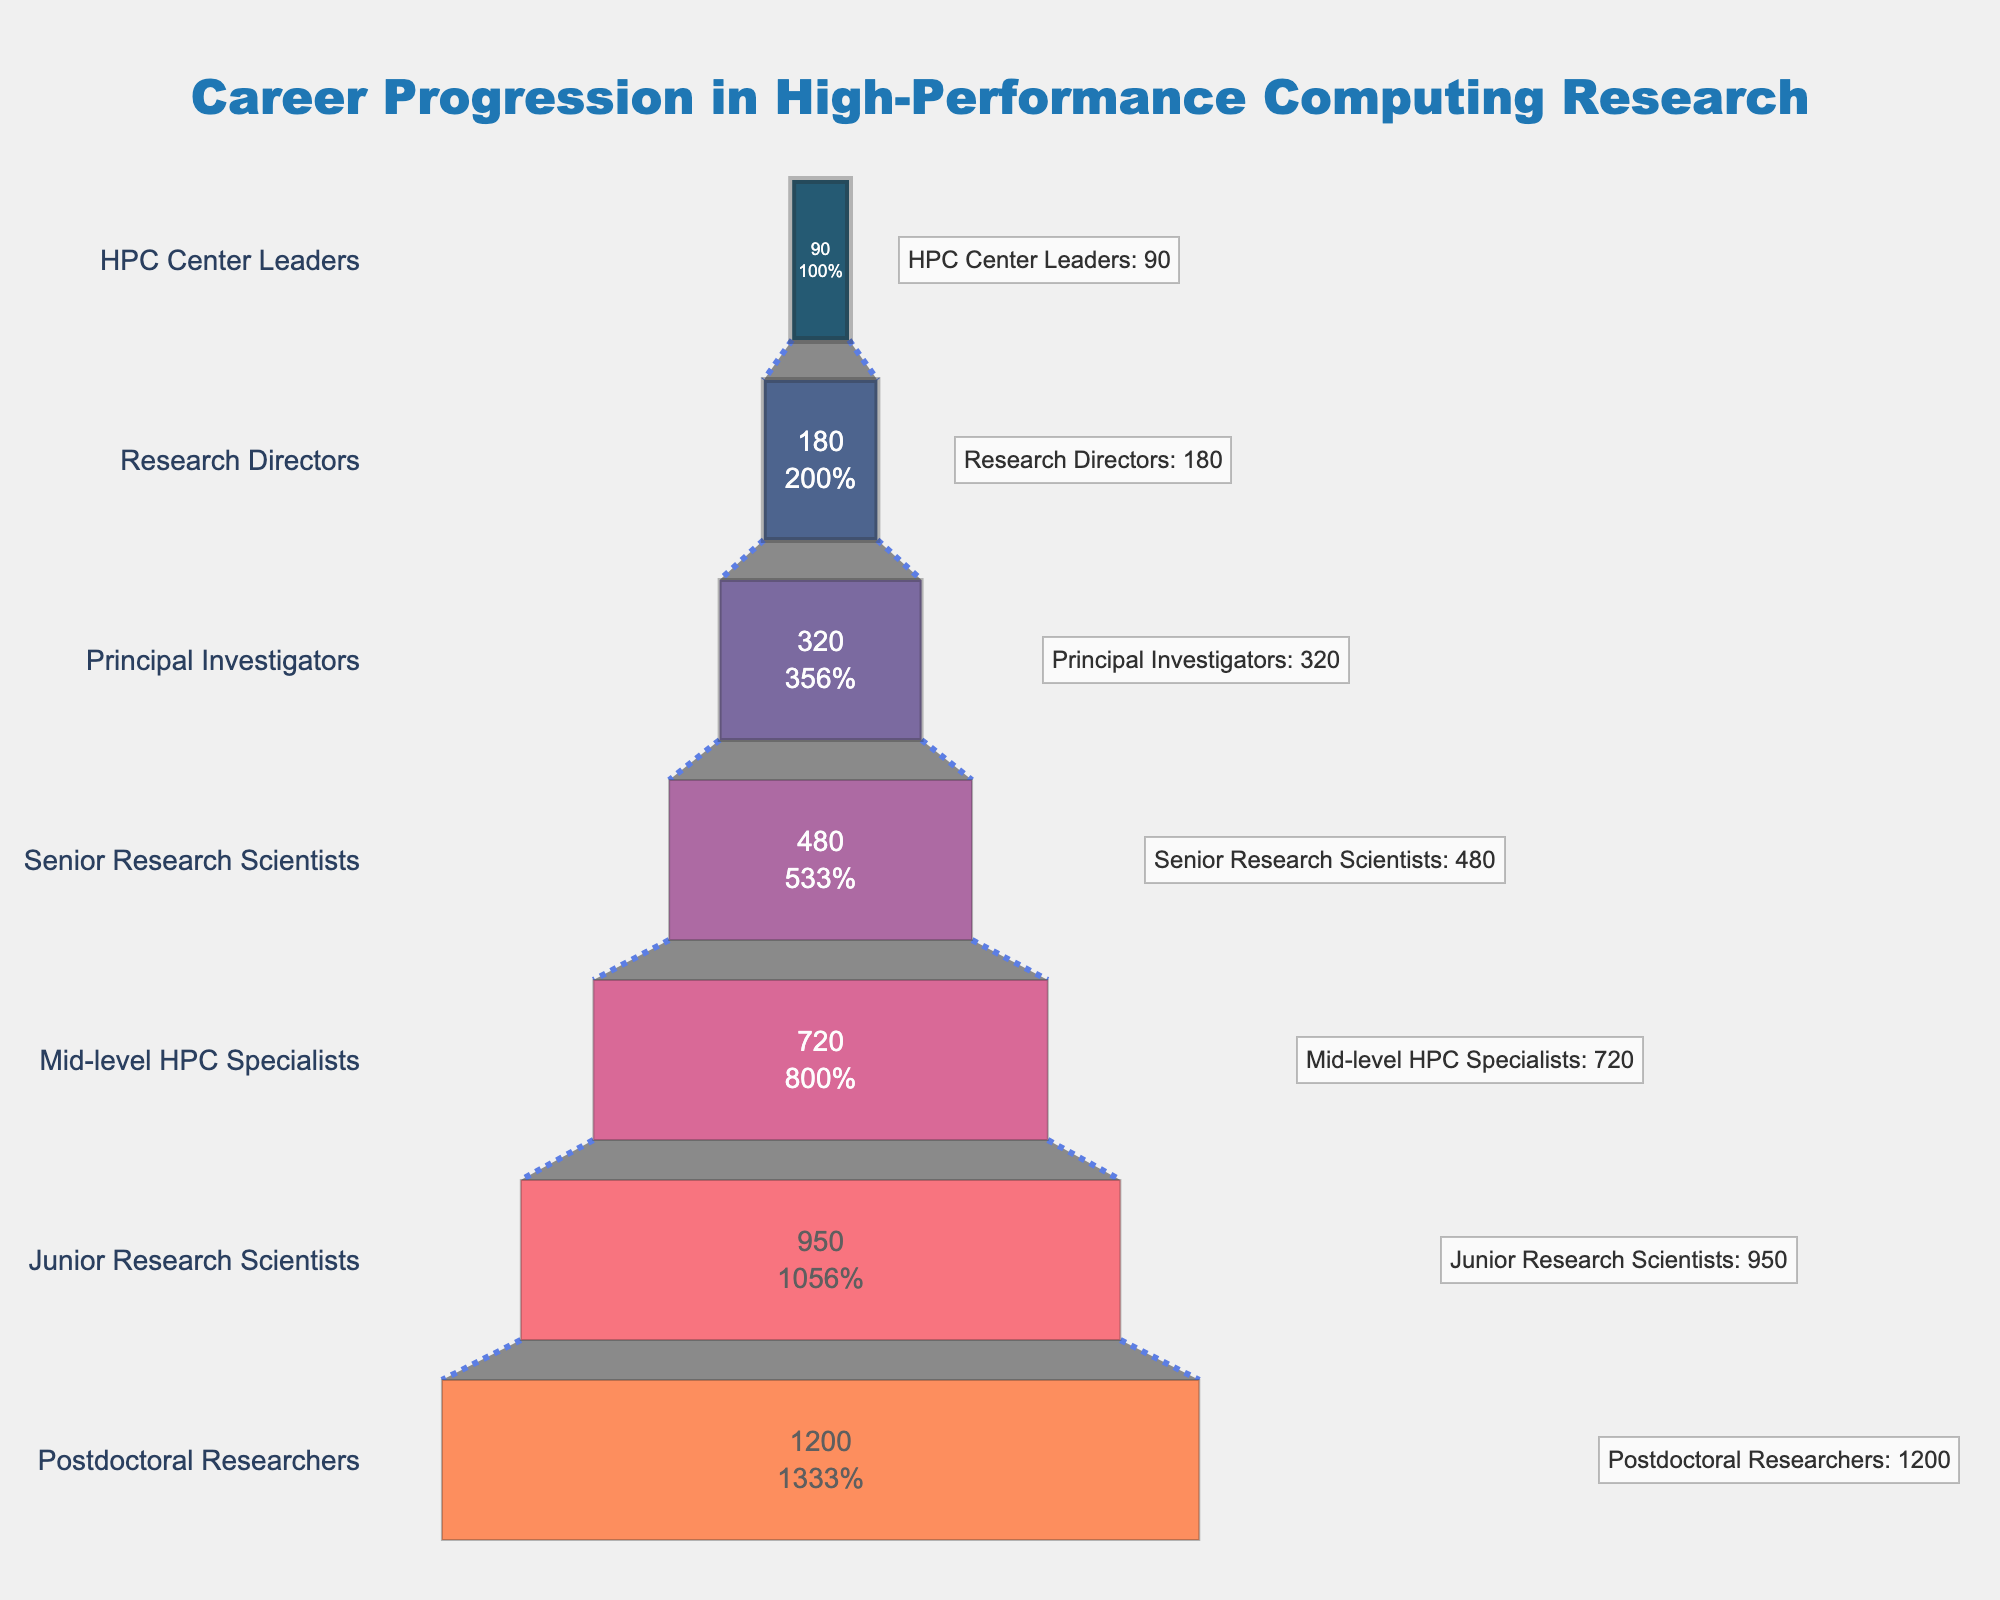how many career stages are there in high-performance computing research based on the funnel chart? The funnel chart displays the career progression and each distinct section of the chart corresponds to a career stage. Counting these sections from the top to the bottom gives the total number of stages.
Answer: 7 which career stage has the highest number of researchers? The top section of the funnel chart represents the stage with the highest number of researchers. This section is labeled "Postdoctoral Researchers" with a value of 1200 researchers.
Answer: Postdoctoral Researchers how does the number of junior research scientists compare to mid-level hpc specialists? By referring to the funnel chart, the section for Junior Research Scientists shows 950 researchers, and the section for Mid-level HPC Specialists shows 720 researchers. Comparing these two values, Junior Research Scientists have more researchers than Mid-level HPC Specialists.
Answer: Junior Research Scientists have more researchers what is the combined total number of researchers in the first three career stages? The first three career stages are "Postdoctoral Researchers" with 1200, "Junior Research Scientists" with 950, and "Mid-level HPC Specialists" with 720 researchers. Adding these numbers: 1200 + 950 + 720 = 2870.
Answer: 2870 what percentage of researchers are in the principal investigators stage? According to the funnel chart, there are 320 researchers in the "Principal Investigators" stage. The total number of researchers in all stages is 1200 + 950 + 720 + 480 + 320 + 180 + 90 = 3940. The percentage is calculated as (320 / 3940) * 100 ≈ 8.12%.
Answer: ~8.12% are there more research directors or hpc center leaders? The funnel chart shows that there are 180 Research Directors and 90 HPC Center Leaders. Comparing these two values, there are more Research Directors than HPC Center Leaders.
Answer: More Research Directors what is the difference in the number of researchers between senior research scientists and research directors? Referring to the funnel chart, Senior Research Scientists number 480 and Research Directors number 180. The difference can be calculated as 480 - 180 = 300.
Answer: 300 what is the visual appearance of the chart's title? The chart title is located at the top center of the funnel chart, with text stating "Career Progression in High-Performance Computing Research." It is styled with a size of 24, colored in #1f77b4, and uses the Arial Black font.
Answer: It is centered, reads "Career Progression in High-Performance Computing Research," and is styled with 24-size Arial Black font in #1f77b4 color 